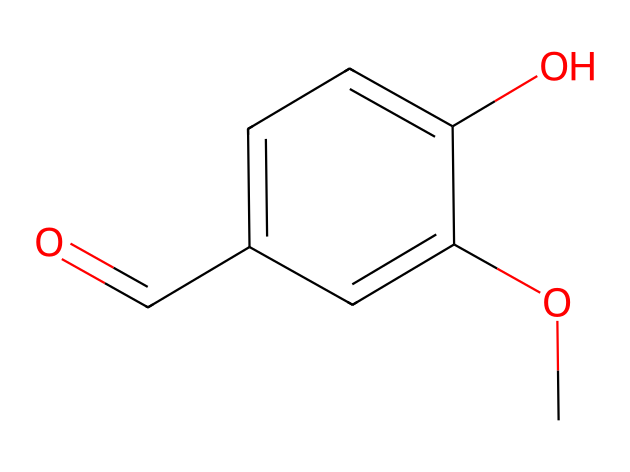What is the functional group present in vanillin? The chemical structure shows a carbonyl group (C=O) attached to a carbon atom, identifying it as an aldehyde.
Answer: aldehyde How many carbon atoms are in vanillin? Counting the carbon atoms in the SMILES representation reveals a total of eight carbon atoms.
Answer: eight What is the total number of oxygen atoms in vanillin? Analyzing the structure indicates there are two oxygen atoms: one in the carbonyl group and one in the methoxy group.
Answer: two Which part of the molecule contributes to its flavoring properties? The methoxy group (-OCH3) and the aldehyde group (C=O) both play key roles in its characteristic flavor profile.
Answer: methoxy group Is vanillin a saturated or unsaturated compound? The presence of a carbonyl double bond in the aldehyde group indicates that vanillin is an unsaturated compound.
Answer: unsaturated What is the primary type of reaction that aldehydes, like vanillin, typically undergo? Aldehydes can undergo oxidation reactions, converting them into carboxylic acids. This is a defining characteristic of aldehydes.
Answer: oxidation 